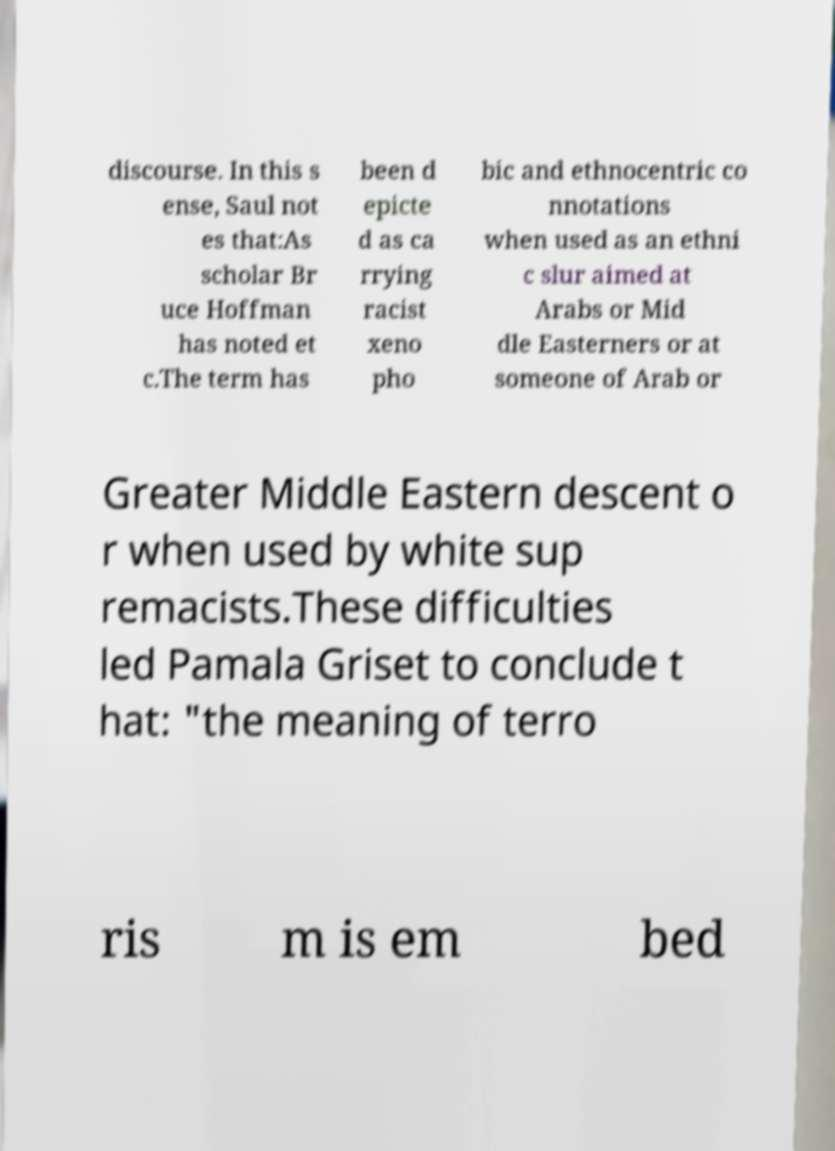For documentation purposes, I need the text within this image transcribed. Could you provide that? discourse. In this s ense, Saul not es that:As scholar Br uce Hoffman has noted et c.The term has been d epicte d as ca rrying racist xeno pho bic and ethnocentric co nnotations when used as an ethni c slur aimed at Arabs or Mid dle Easterners or at someone of Arab or Greater Middle Eastern descent o r when used by white sup remacists.These difficulties led Pamala Griset to conclude t hat: "the meaning of terro ris m is em bed 